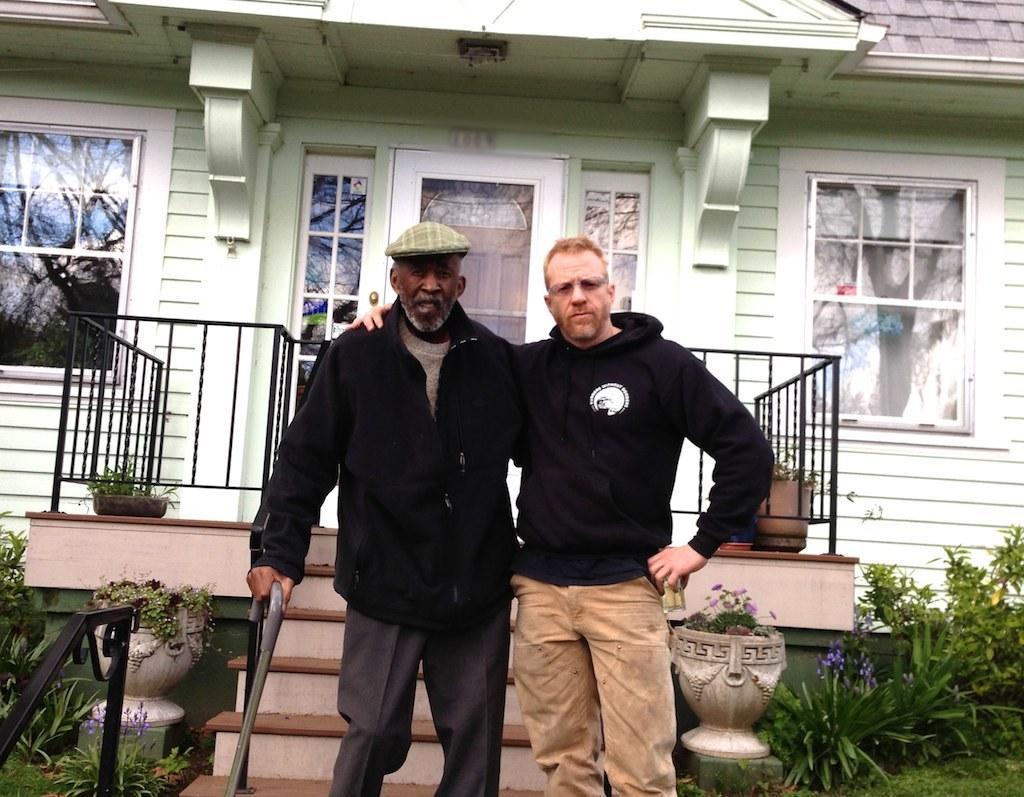Describe this image in one or two sentences. In this image, I can see two men standing. In the background, It looks like a house with a door, windows, stairs and the iron grilles. I can see the flower pots with the plants in it. At the bottom of the image, these look like the Plants. 